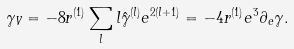<formula> <loc_0><loc_0><loc_500><loc_500>\gamma _ { V } = - 8 r ^ { ( 1 ) } \sum _ { l } l \hat { \gamma } ^ { ( l ) } e ^ { 2 ( l + 1 ) } = - 4 r ^ { ( 1 ) } e ^ { 3 } \partial _ { e } \gamma .</formula> 